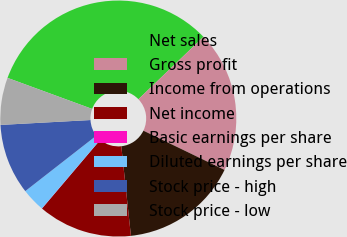Convert chart. <chart><loc_0><loc_0><loc_500><loc_500><pie_chart><fcel>Net sales<fcel>Gross profit<fcel>Income from operations<fcel>Net income<fcel>Basic earnings per share<fcel>Diluted earnings per share<fcel>Stock price - high<fcel>Stock price - low<nl><fcel>32.23%<fcel>19.34%<fcel>16.12%<fcel>12.9%<fcel>0.02%<fcel>3.24%<fcel>9.68%<fcel>6.46%<nl></chart> 